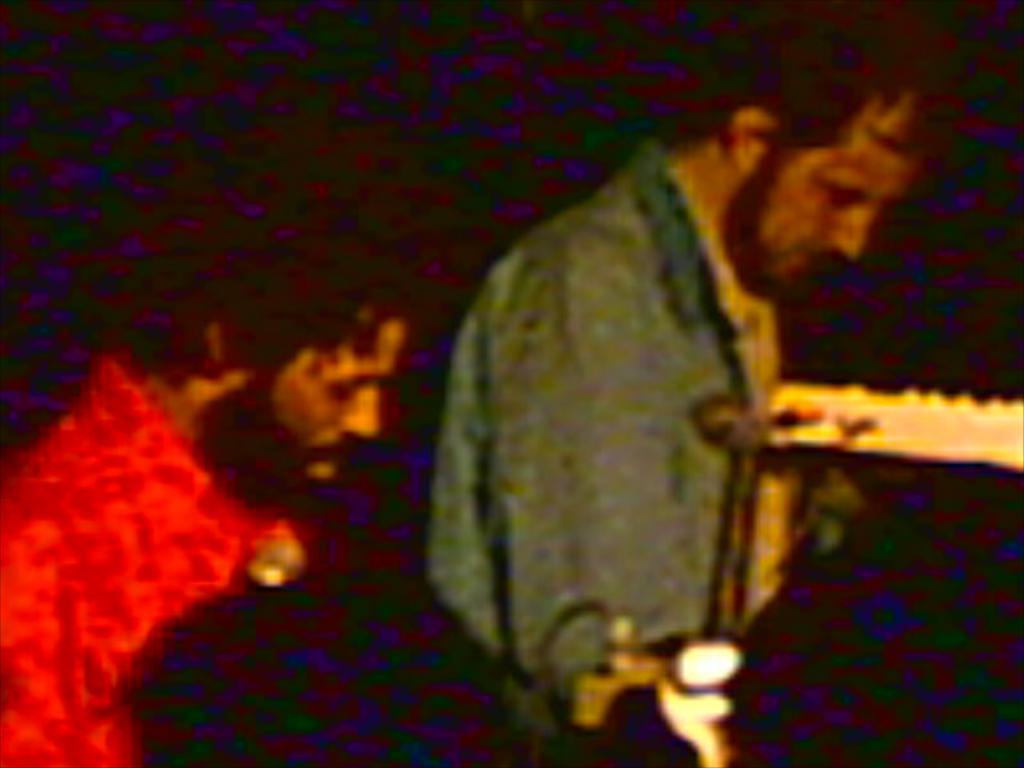Can you describe this image briefly? In this image there are two persons, and there is dark background. 